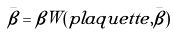Convert formula to latex. <formula><loc_0><loc_0><loc_500><loc_500>\bar { \beta } = \beta W ( p l a q u e t t e , \bar { \beta } )</formula> 